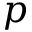<formula> <loc_0><loc_0><loc_500><loc_500>p</formula> 